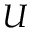Convert formula to latex. <formula><loc_0><loc_0><loc_500><loc_500>U</formula> 